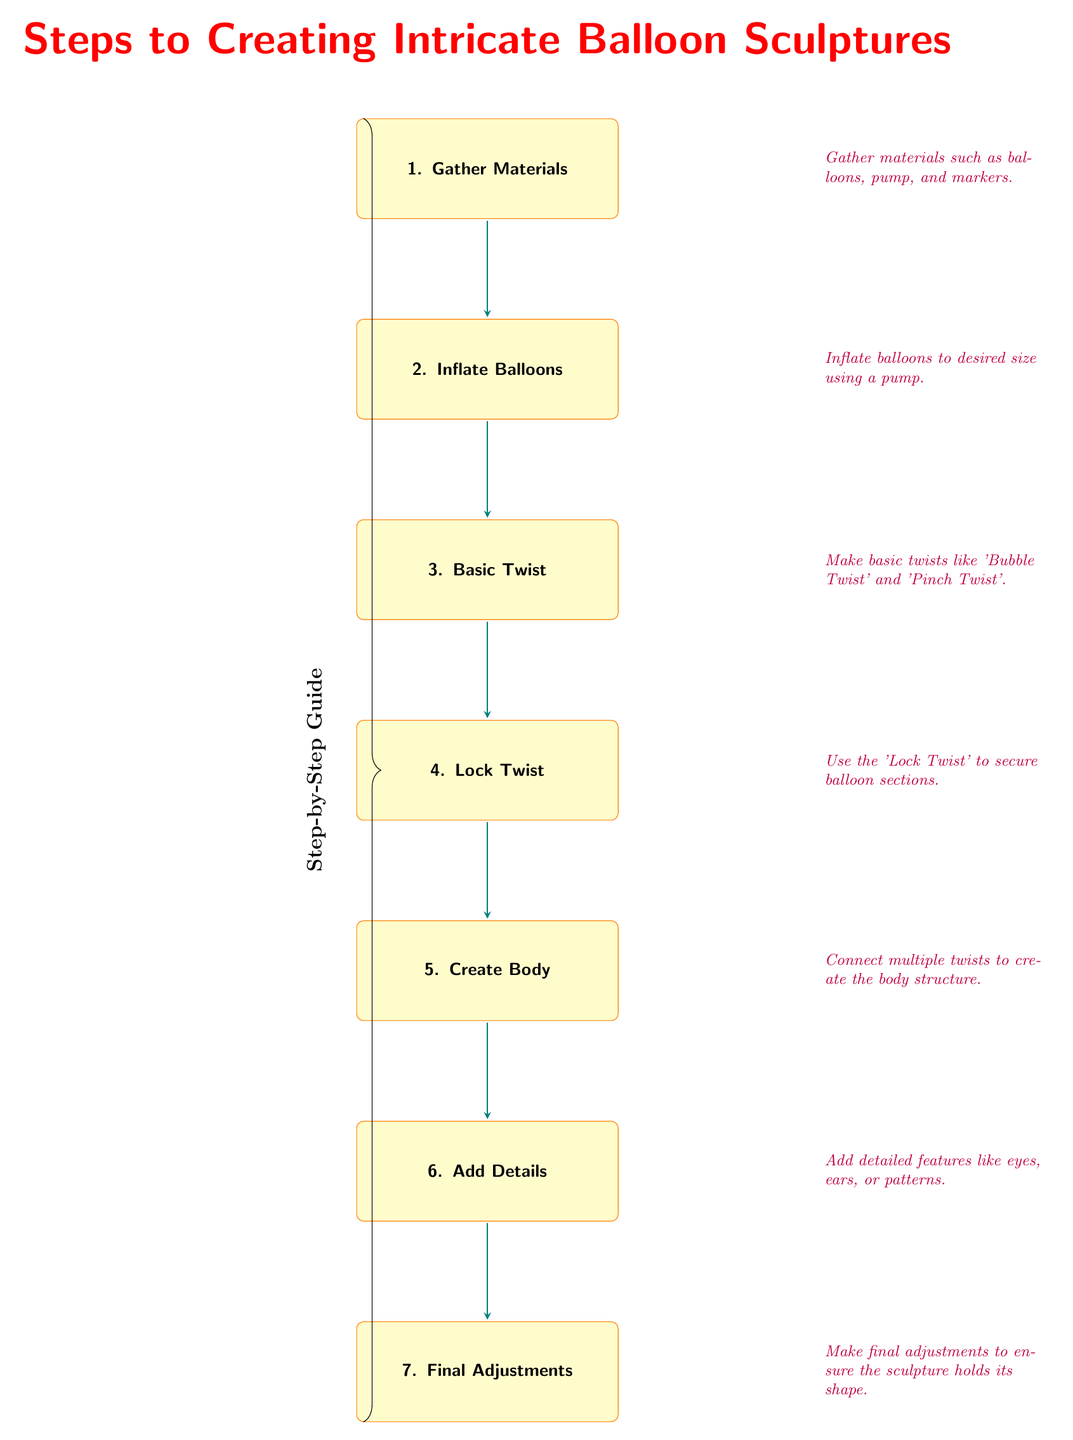What is the first step in creating balloon sculptures? The diagram indicates that the first step is "Gather Materials." This is clearly stated in the first box at the top of the diagram.
Answer: Gather Materials How many steps are mentioned in the diagram? Counting all the steps listed, there are seven distinct steps provided in the diagram.
Answer: Seven What is the purpose of the 'Lock Twist'? The diagram's explanation next to the 'Lock Twist' step states that it is used to secure balloon sections. This indicates its role in the balloon-making process.
Answer: Secure balloon sections Which step comes immediately after 'Basic Twist'? From the flow of the diagram, the step immediately following 'Basic Twist' is 'Lock Twist', as indicated by the arrows connecting the boxes.
Answer: Lock Twist What materials should be gathered in the first step? The note beside the first step specifies that the materials include balloons, pump, and markers, which are essential for starting the balloon sculpture process.
Answer: Balloons, pump, markers What is the last step in this guide? The final step listed in the diagram is 'Final Adjustments', which emphasizes the importance of ensuring the sculpture holds its shape.
Answer: Final Adjustments Which arrows in the diagram indicate a sequence of steps? The arrows drawn between each box in the diagram demonstrate the sequence, as they connect all steps from 'Gather Materials' to 'Final Adjustments', illustrating the flow of instructions.
Answer: Arrows 